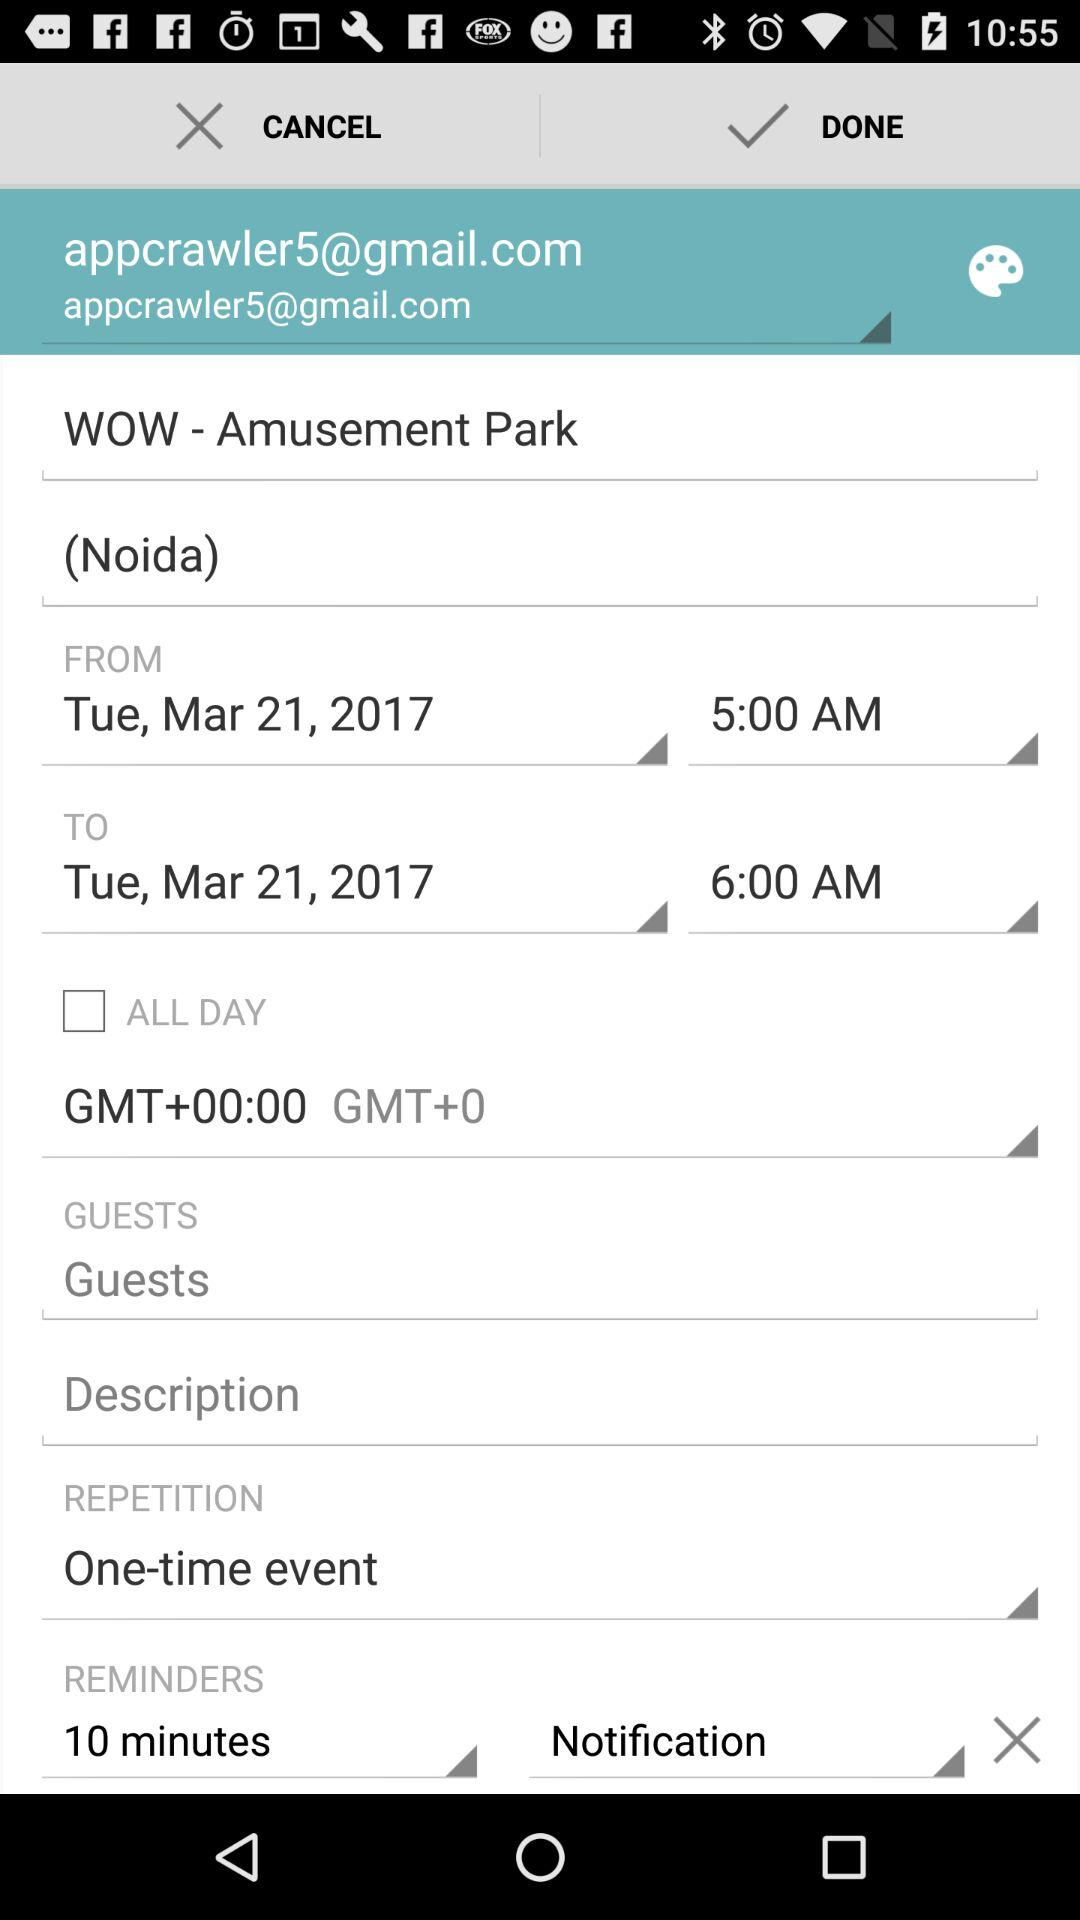What's the repetition status? The status of repetition is "One-time event". 